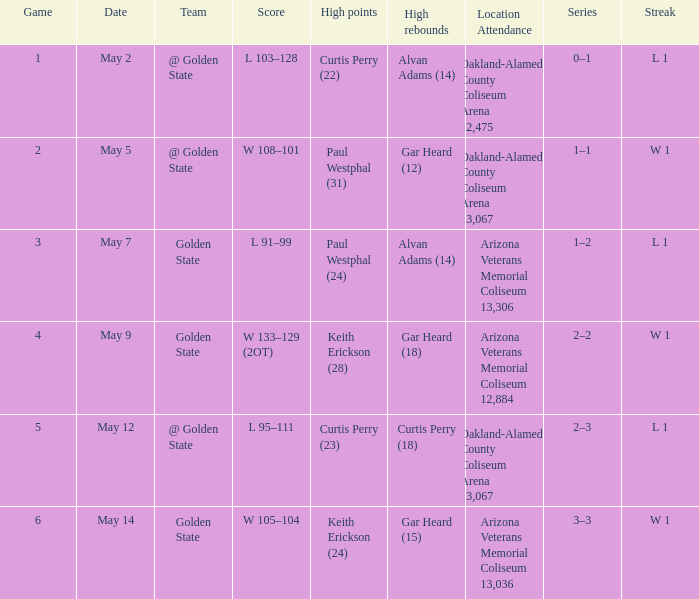On may 9, what was their consecutive number of victories or defeats in games? W 1. 